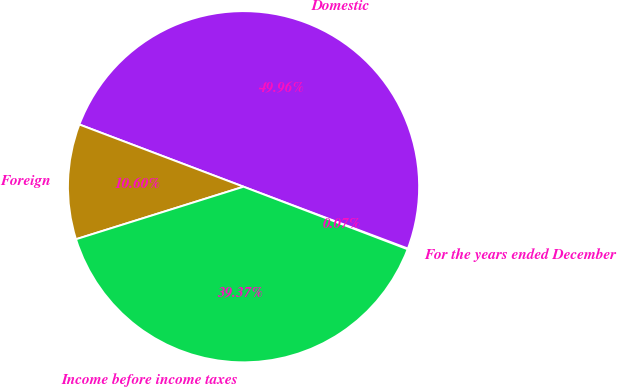<chart> <loc_0><loc_0><loc_500><loc_500><pie_chart><fcel>For the years ended December<fcel>Domestic<fcel>Foreign<fcel>Income before income taxes<nl><fcel>0.07%<fcel>49.96%<fcel>10.6%<fcel>39.37%<nl></chart> 